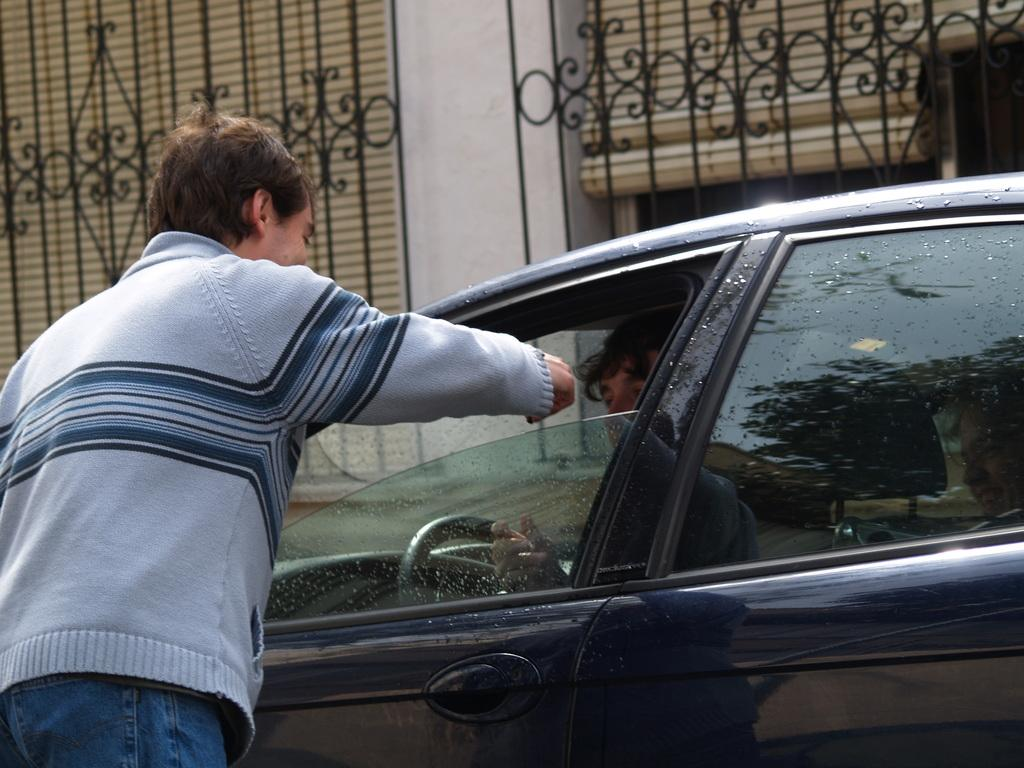What is the person in the image doing? There is a person standing outside in the image. What else can be seen in the image besides the person? There is a vehicle in the image, and there is a person sitting inside the car. What type of structure is visible in the image? There is a wall in the image, and there is a gate in the image. What type of part can be seen in the image? There is no specific part mentioned in the image; it features a person standing outside, a vehicle, a person sitting inside the car, a wall, and a gate. Can you see any rats in the image? There are no rats present in the image. 